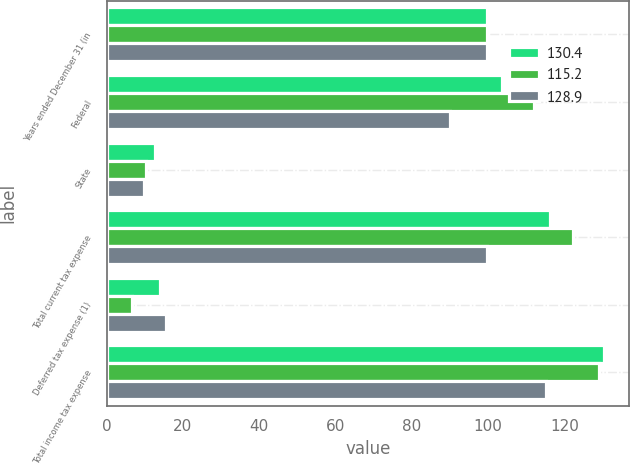<chart> <loc_0><loc_0><loc_500><loc_500><stacked_bar_chart><ecel><fcel>Years ended December 31 (in<fcel>Federal<fcel>State<fcel>Total current tax expense<fcel>Deferred tax expense (1)<fcel>Total income tax expense<nl><fcel>130.4<fcel>99.7<fcel>103.6<fcel>12.7<fcel>116.3<fcel>14.1<fcel>130.4<nl><fcel>115.2<fcel>99.7<fcel>111.9<fcel>10.3<fcel>122.2<fcel>6.7<fcel>128.9<nl><fcel>128.9<fcel>99.7<fcel>89.9<fcel>9.8<fcel>99.7<fcel>15.5<fcel>115.2<nl></chart> 